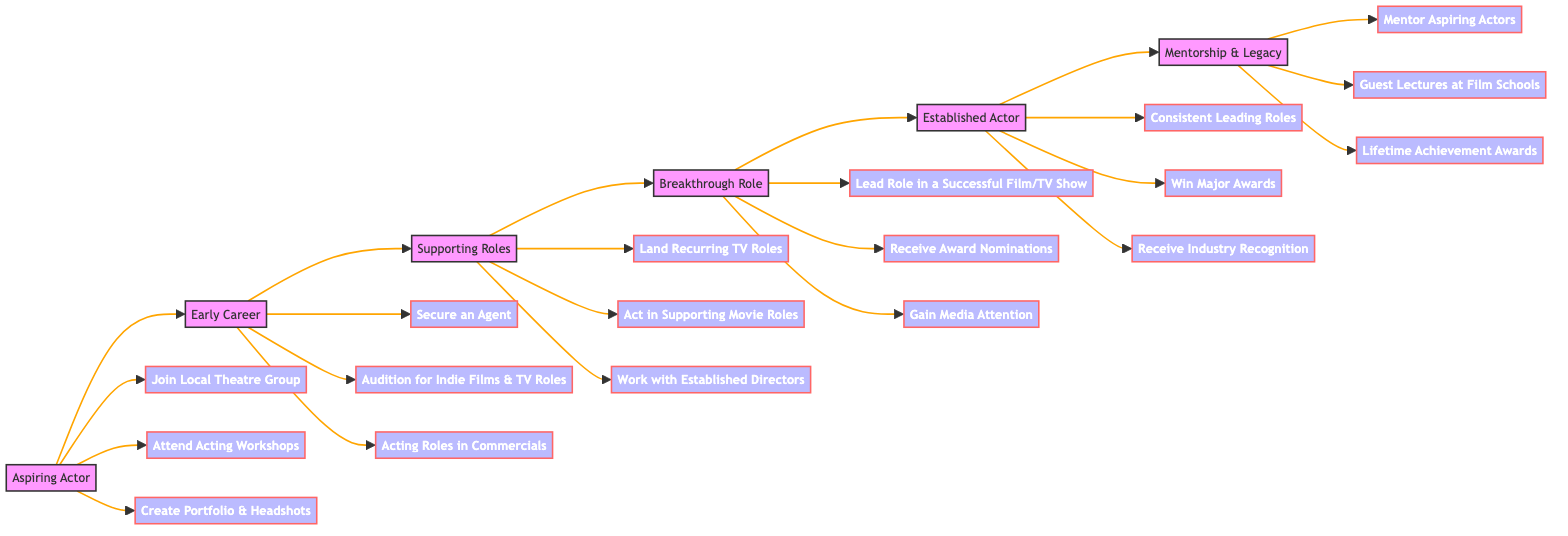What is the first stage in the career pathway? The diagram shows that the first stage of the career pathway is "Aspiring Actor." This is indicated as the starting point from which the flowchart proceeds.
Answer: Aspiring Actor How many milestones are in the Established Actor stage? In the "Established Actor" stage, there are three milestones listed: "Consistent Leading Roles," "Win Major Awards," and "Receive Industry Recognition." Counting them gives a total of three milestones.
Answer: 3 What milestone comes after landing recurring TV roles? The milestone that follows "Land Recurring TV Roles" is "Act in Supporting Movie Roles," as the diagram indicates the progression downwards from the "Supporting Roles" stage.
Answer: Act in Supporting Movie Roles Which stage directly precedes the Mentorship & Legacy stage? The stage that immediately comes before the "Mentorship & Legacy" stage is "Established Actor," as shown by the directional arrows connecting the stages in the flowchart.
Answer: Established Actor What is the total number of stages in the career pathway? The diagram lists six distinct stages: "Aspiring Actor," "Early Career," "Supporting Roles," "Breakthrough Role," "Established Actor," and "Mentorship & Legacy." Thus, the total number of stages is six.
Answer: 6 Which milestone is associated with gaining media attention? The milestone associated with gaining media attention is "Gain Media Attention," which is located under the "Breakthrough Role" stage in the diagram.
Answer: Gain Media Attention In which stage would you find the milestone "Guest Lectures at Film Schools"? The milestone "Guest Lectures at Film Schools" is found within the "Mentorship & Legacy" stage, as indicated by its position in the diagram.
Answer: Mentorship & Legacy How many nodes are present in the Supporting Roles stage? The "Supporting Roles" stage has three nodes representing milestones: "Land Recurring TV Roles," "Act in Supporting Movie Roles," and "Work with Established Directors." Thus, there are three nodes in this stage.
Answer: 3 What is the relationship between the "Breakthrough Role" and the "Established Actor" stages? The "Breakthrough Role" stage leads directly to the "Established Actor" stage, as the diagram arrows indicate a sequential relationship where an actor achieving a breakthrough role progresses to becoming an established actor.
Answer: Direct progression 